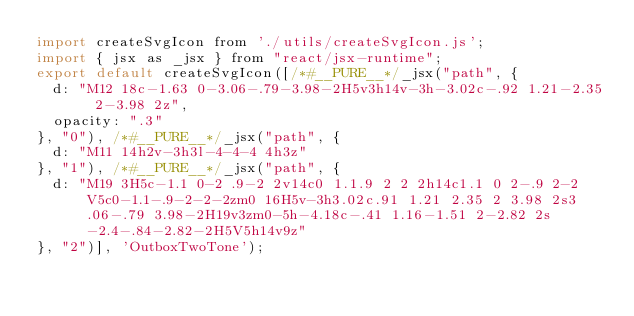<code> <loc_0><loc_0><loc_500><loc_500><_JavaScript_>import createSvgIcon from './utils/createSvgIcon.js';
import { jsx as _jsx } from "react/jsx-runtime";
export default createSvgIcon([/*#__PURE__*/_jsx("path", {
  d: "M12 18c-1.63 0-3.06-.79-3.98-2H5v3h14v-3h-3.02c-.92 1.21-2.35 2-3.98 2z",
  opacity: ".3"
}, "0"), /*#__PURE__*/_jsx("path", {
  d: "M11 14h2v-3h3l-4-4-4 4h3z"
}, "1"), /*#__PURE__*/_jsx("path", {
  d: "M19 3H5c-1.1 0-2 .9-2 2v14c0 1.1.9 2 2 2h14c1.1 0 2-.9 2-2V5c0-1.1-.9-2-2-2zm0 16H5v-3h3.02c.91 1.21 2.35 2 3.98 2s3.06-.79 3.98-2H19v3zm0-5h-4.18c-.41 1.16-1.51 2-2.82 2s-2.4-.84-2.82-2H5V5h14v9z"
}, "2")], 'OutboxTwoTone');</code> 